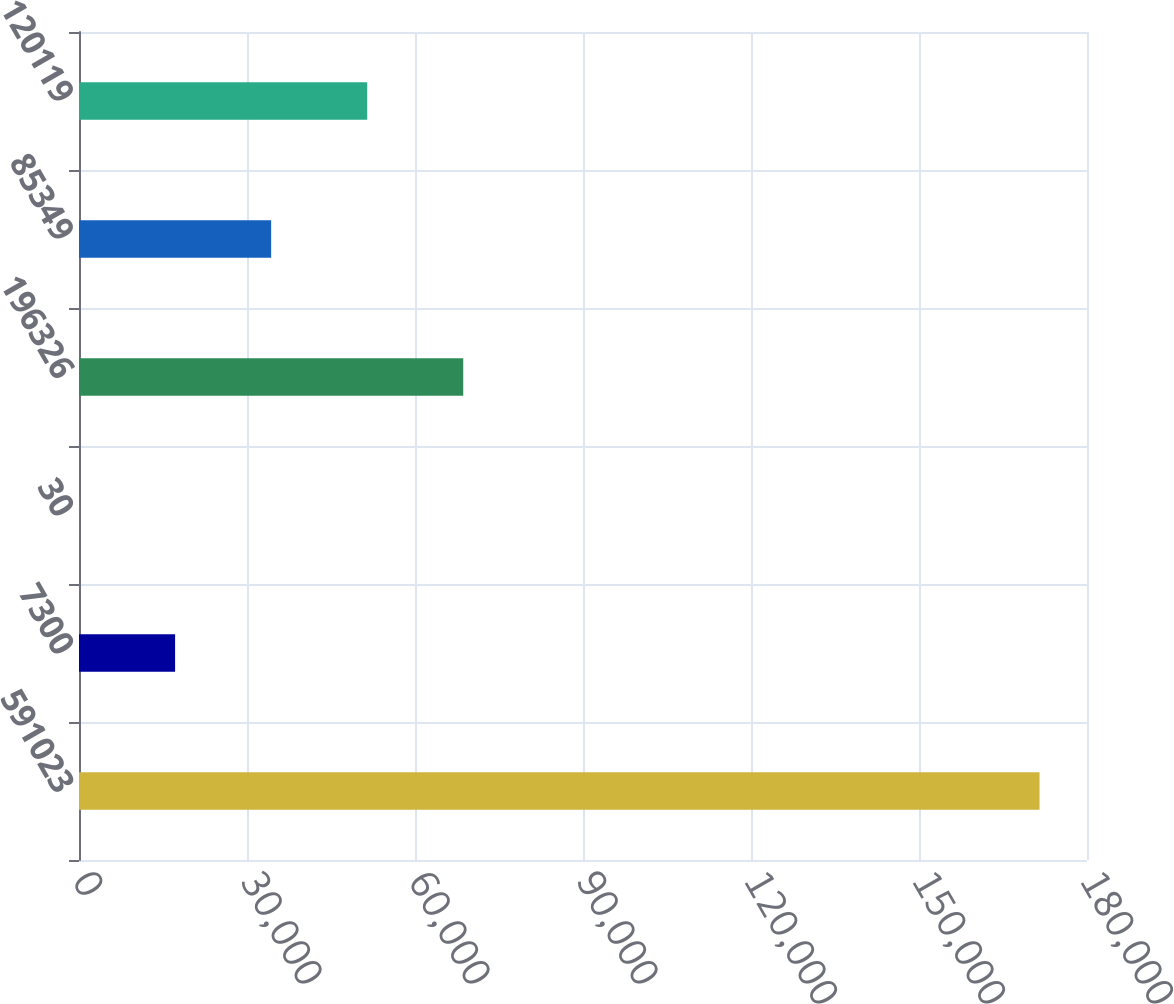Convert chart to OTSL. <chart><loc_0><loc_0><loc_500><loc_500><bar_chart><fcel>591023<fcel>7300<fcel>30<fcel>196326<fcel>85349<fcel>120119<nl><fcel>171526<fcel>17159.8<fcel>8<fcel>68615.2<fcel>34311.6<fcel>51463.4<nl></chart> 